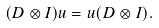<formula> <loc_0><loc_0><loc_500><loc_500>( D \otimes I ) u = u ( D \otimes I ) .</formula> 